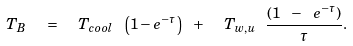Convert formula to latex. <formula><loc_0><loc_0><loc_500><loc_500>T _ { B } \ \ = \ \ T _ { c o o l } \ \left ( 1 - e ^ { - \tau } \right ) \ + \ \ T _ { w , u } \ \frac { ( 1 \ - \ e ^ { - \tau } ) } { \tau } .</formula> 